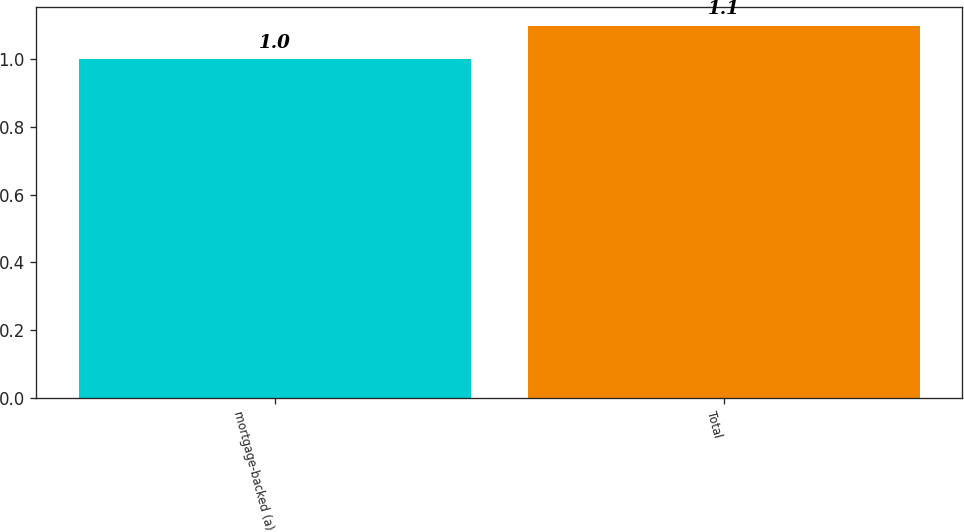<chart> <loc_0><loc_0><loc_500><loc_500><bar_chart><fcel>mortgage-backed (a)<fcel>Total<nl><fcel>1<fcel>1.1<nl></chart> 